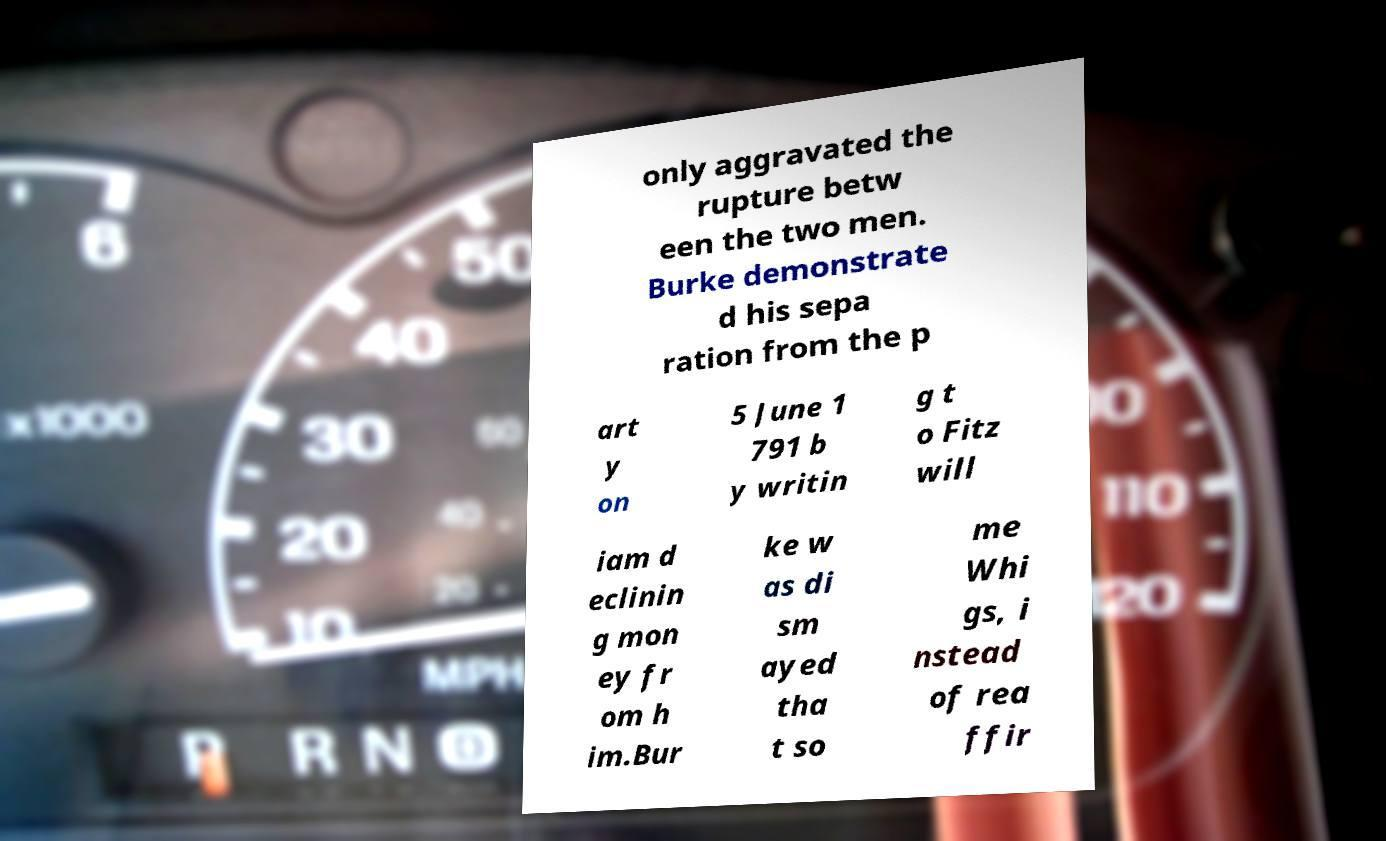Could you extract and type out the text from this image? only aggravated the rupture betw een the two men. Burke demonstrate d his sepa ration from the p art y on 5 June 1 791 b y writin g t o Fitz will iam d eclinin g mon ey fr om h im.Bur ke w as di sm ayed tha t so me Whi gs, i nstead of rea ffir 